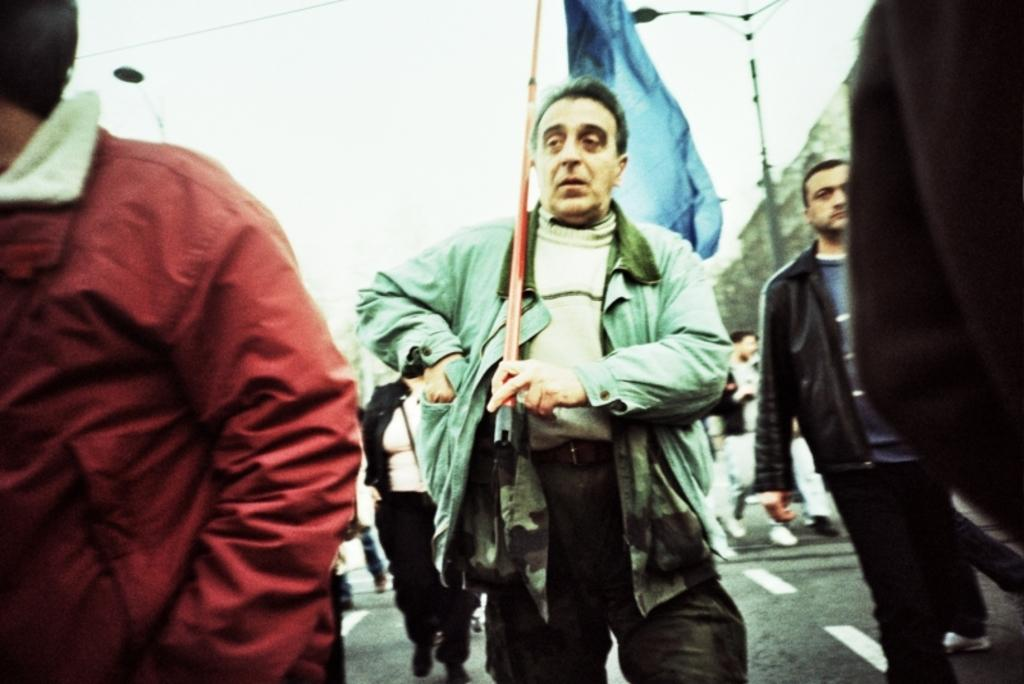What is happening with the group of people in the image? The people are walking in the image. What can be seen in the background of the image? There is a street lamp, a flag, and buildings visible in the image. What is visible in the sky in the image? The sky is visible in the image. What type of juice is being served at the wax museum in the image? There is no mention of juice or a wax museum in the image; it features a group of people walking with a street lamp, flag, and buildings in the background. 